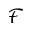<formula> <loc_0><loc_0><loc_500><loc_500>\mathcal { F }</formula> 